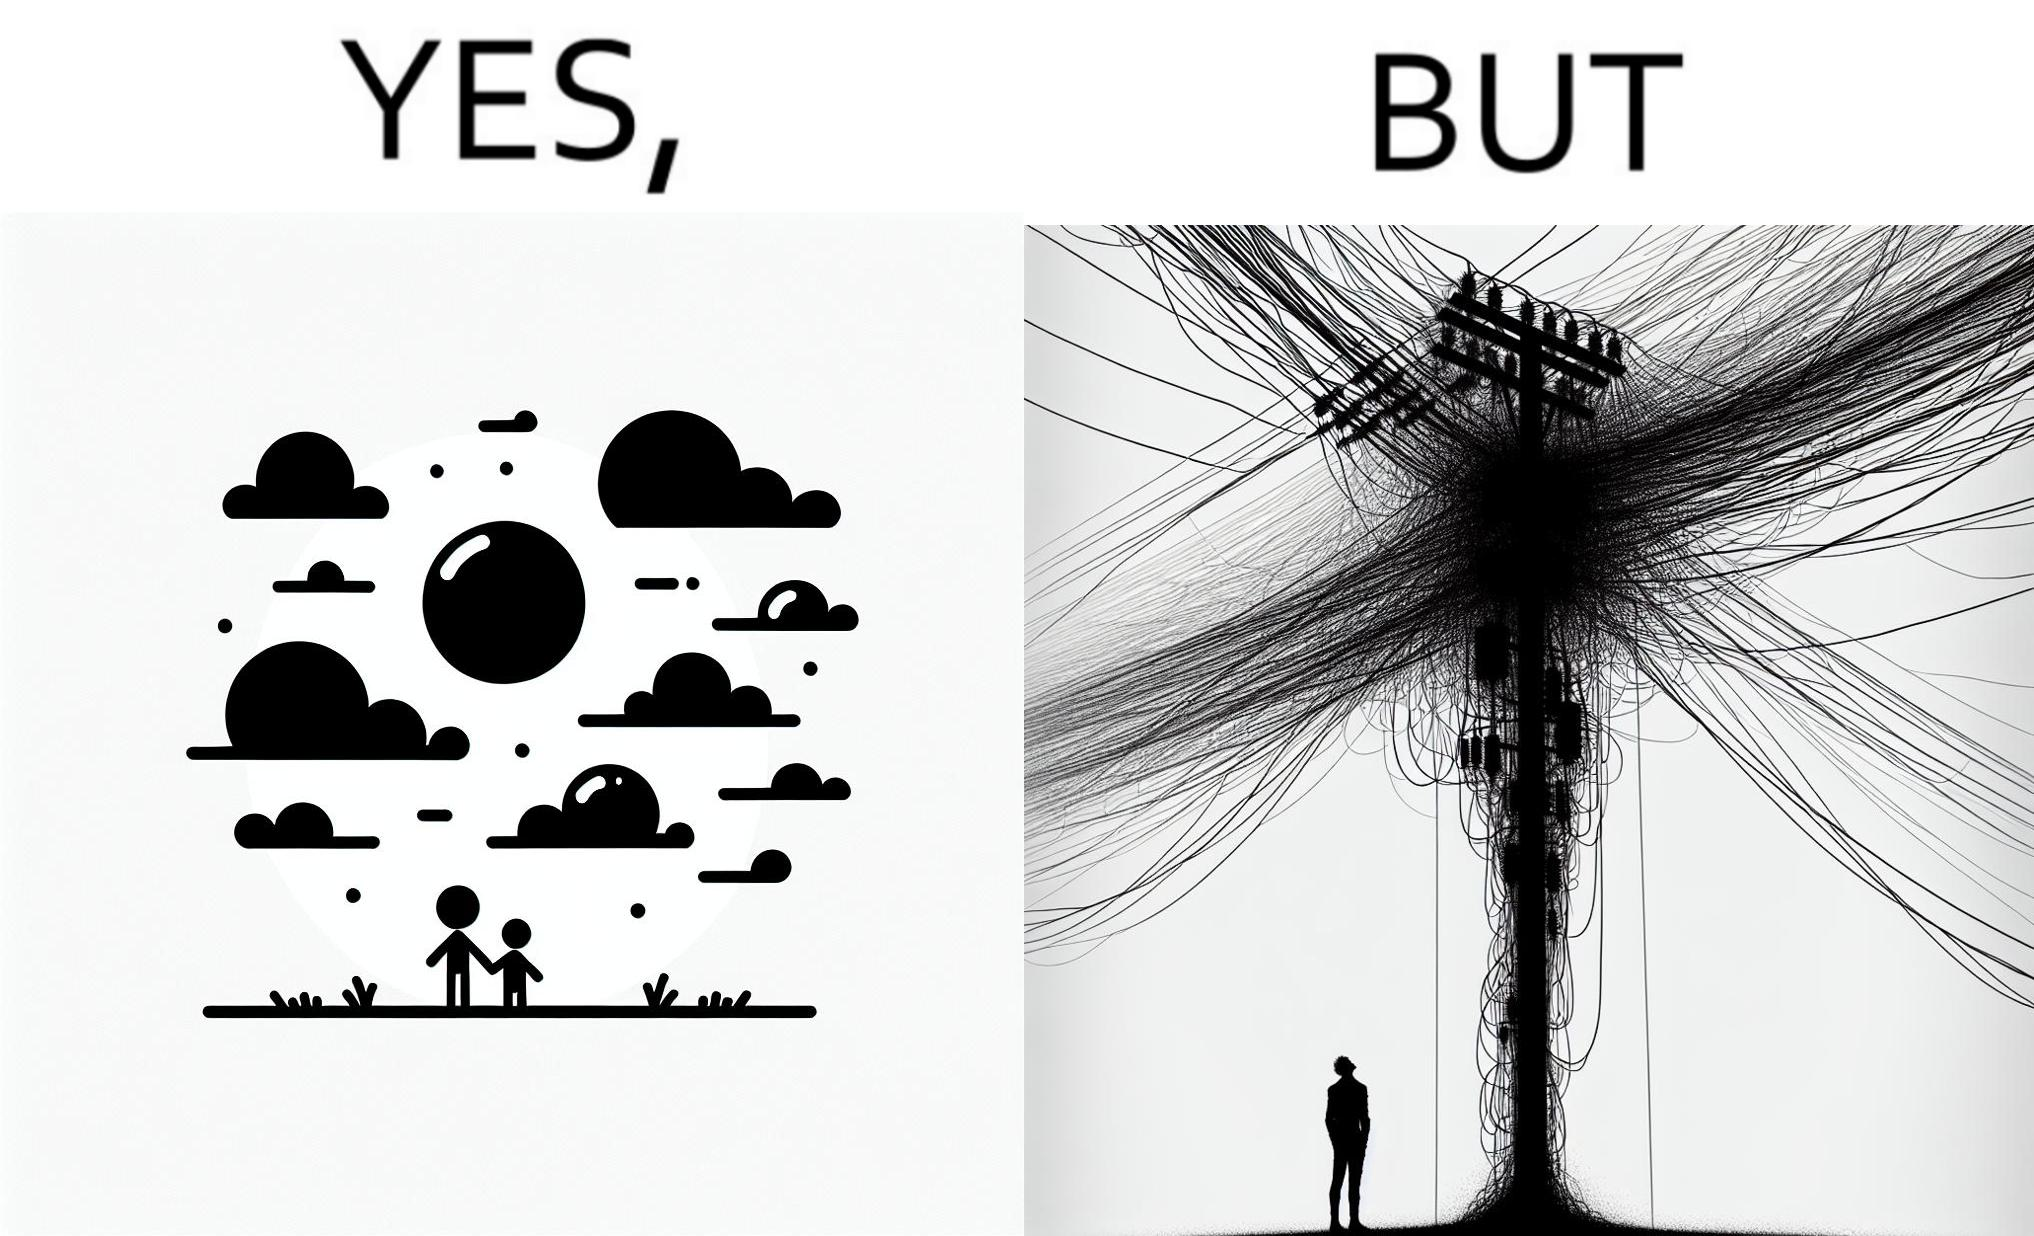Describe the satirical element in this image. The image is ironic, because in the first image clear sky is visible but in the second image the same view is getting blocked due to the electricity pole 